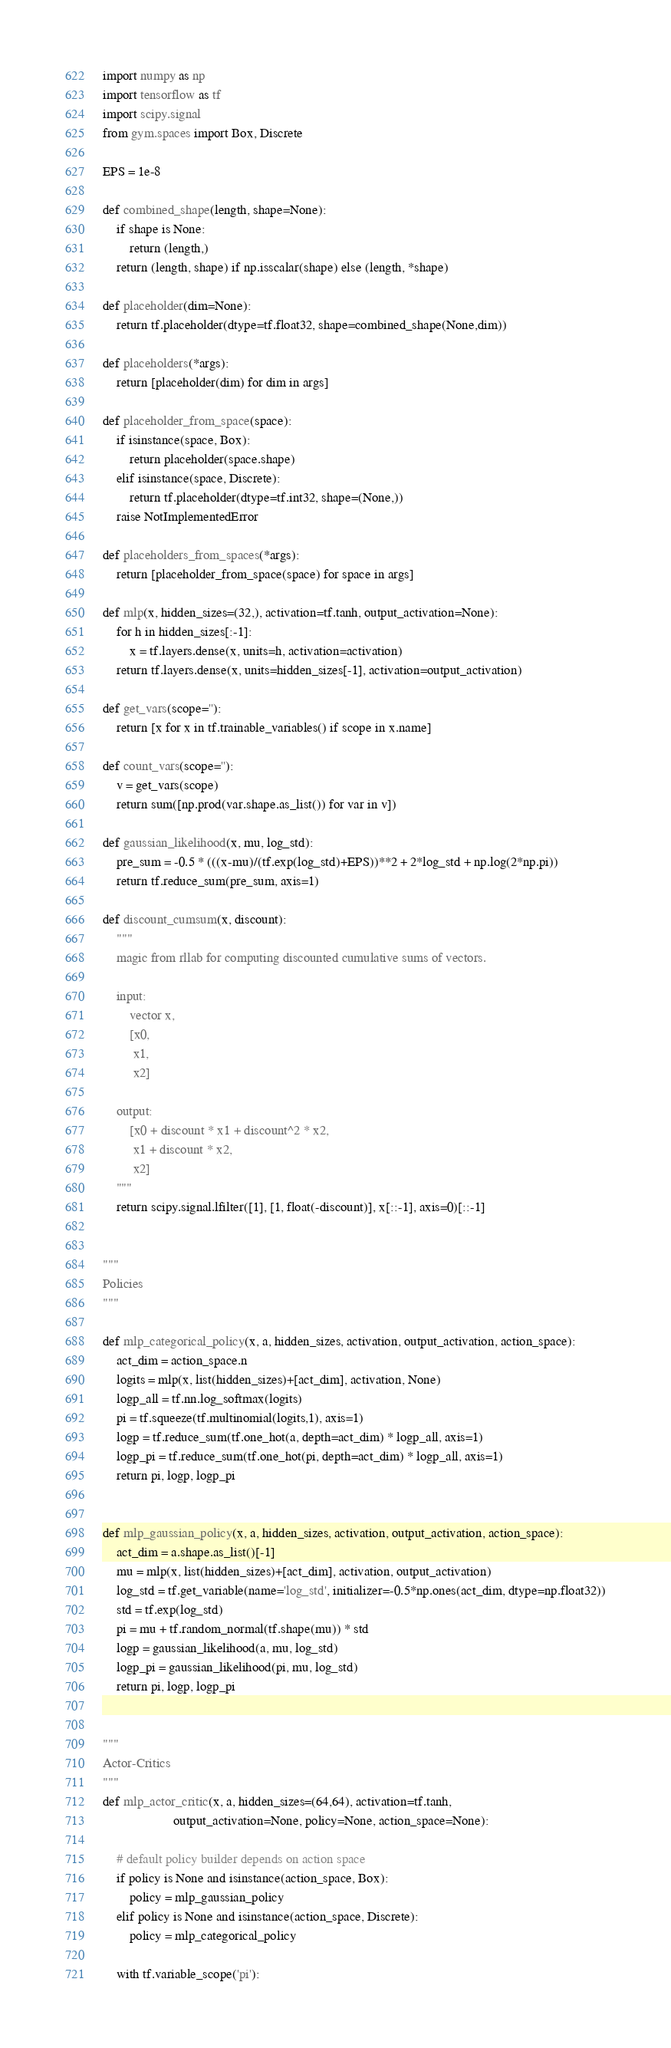<code> <loc_0><loc_0><loc_500><loc_500><_Python_>import numpy as np
import tensorflow as tf
import scipy.signal
from gym.spaces import Box, Discrete

EPS = 1e-8

def combined_shape(length, shape=None):
    if shape is None:
        return (length,)
    return (length, shape) if np.isscalar(shape) else (length, *shape)

def placeholder(dim=None):
    return tf.placeholder(dtype=tf.float32, shape=combined_shape(None,dim))

def placeholders(*args):
    return [placeholder(dim) for dim in args]

def placeholder_from_space(space):
    if isinstance(space, Box):
        return placeholder(space.shape)
    elif isinstance(space, Discrete):
        return tf.placeholder(dtype=tf.int32, shape=(None,))
    raise NotImplementedError

def placeholders_from_spaces(*args):
    return [placeholder_from_space(space) for space in args]

def mlp(x, hidden_sizes=(32,), activation=tf.tanh, output_activation=None):
    for h in hidden_sizes[:-1]:
        x = tf.layers.dense(x, units=h, activation=activation)
    return tf.layers.dense(x, units=hidden_sizes[-1], activation=output_activation)

def get_vars(scope=''):
    return [x for x in tf.trainable_variables() if scope in x.name]

def count_vars(scope=''):
    v = get_vars(scope)
    return sum([np.prod(var.shape.as_list()) for var in v])

def gaussian_likelihood(x, mu, log_std):
    pre_sum = -0.5 * (((x-mu)/(tf.exp(log_std)+EPS))**2 + 2*log_std + np.log(2*np.pi))
    return tf.reduce_sum(pre_sum, axis=1)

def discount_cumsum(x, discount):
    """
    magic from rllab for computing discounted cumulative sums of vectors.

    input: 
        vector x, 
        [x0, 
         x1, 
         x2]

    output:
        [x0 + discount * x1 + discount^2 * x2,  
         x1 + discount * x2,
         x2]
    """
    return scipy.signal.lfilter([1], [1, float(-discount)], x[::-1], axis=0)[::-1]


"""
Policies
"""

def mlp_categorical_policy(x, a, hidden_sizes, activation, output_activation, action_space):
    act_dim = action_space.n
    logits = mlp(x, list(hidden_sizes)+[act_dim], activation, None)
    logp_all = tf.nn.log_softmax(logits)
    pi = tf.squeeze(tf.multinomial(logits,1), axis=1)
    logp = tf.reduce_sum(tf.one_hot(a, depth=act_dim) * logp_all, axis=1)
    logp_pi = tf.reduce_sum(tf.one_hot(pi, depth=act_dim) * logp_all, axis=1)
    return pi, logp, logp_pi


def mlp_gaussian_policy(x, a, hidden_sizes, activation, output_activation, action_space):
    act_dim = a.shape.as_list()[-1]
    mu = mlp(x, list(hidden_sizes)+[act_dim], activation, output_activation)
    log_std = tf.get_variable(name='log_std', initializer=-0.5*np.ones(act_dim, dtype=np.float32))
    std = tf.exp(log_std)
    pi = mu + tf.random_normal(tf.shape(mu)) * std
    logp = gaussian_likelihood(a, mu, log_std)
    logp_pi = gaussian_likelihood(pi, mu, log_std)
    return pi, logp, logp_pi


"""
Actor-Critics
"""
def mlp_actor_critic(x, a, hidden_sizes=(64,64), activation=tf.tanh, 
                     output_activation=None, policy=None, action_space=None):

    # default policy builder depends on action space
    if policy is None and isinstance(action_space, Box):
        policy = mlp_gaussian_policy
    elif policy is None and isinstance(action_space, Discrete):
        policy = mlp_categorical_policy

    with tf.variable_scope('pi'):</code> 